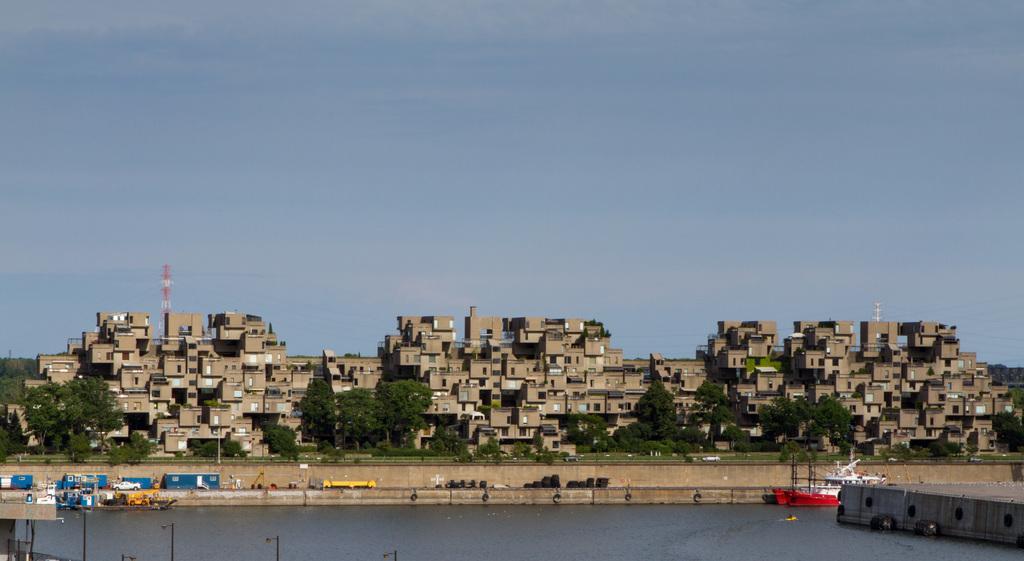In one or two sentences, can you explain what this image depicts? In the image there is a lake in the front with boats in it and behind there are few vehicles going on the road and in the background there are buildings with trees in front of it and above its sky with clouds. 